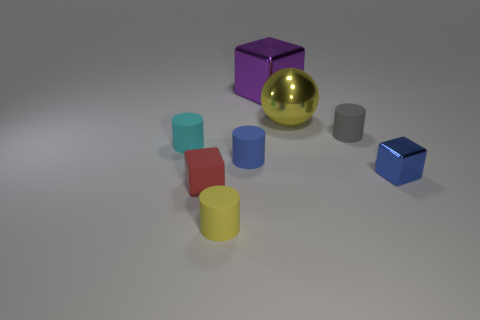Subtract all gray matte cylinders. How many cylinders are left? 3 Add 1 big yellow matte cubes. How many objects exist? 9 Subtract all cyan cylinders. How many cylinders are left? 3 Subtract all spheres. How many objects are left? 7 Subtract 3 blocks. How many blocks are left? 0 Subtract all cyan spheres. How many cyan cylinders are left? 1 Subtract all small yellow cylinders. Subtract all yellow balls. How many objects are left? 6 Add 2 tiny cylinders. How many tiny cylinders are left? 6 Add 3 small blue rubber spheres. How many small blue rubber spheres exist? 3 Subtract 0 cyan blocks. How many objects are left? 8 